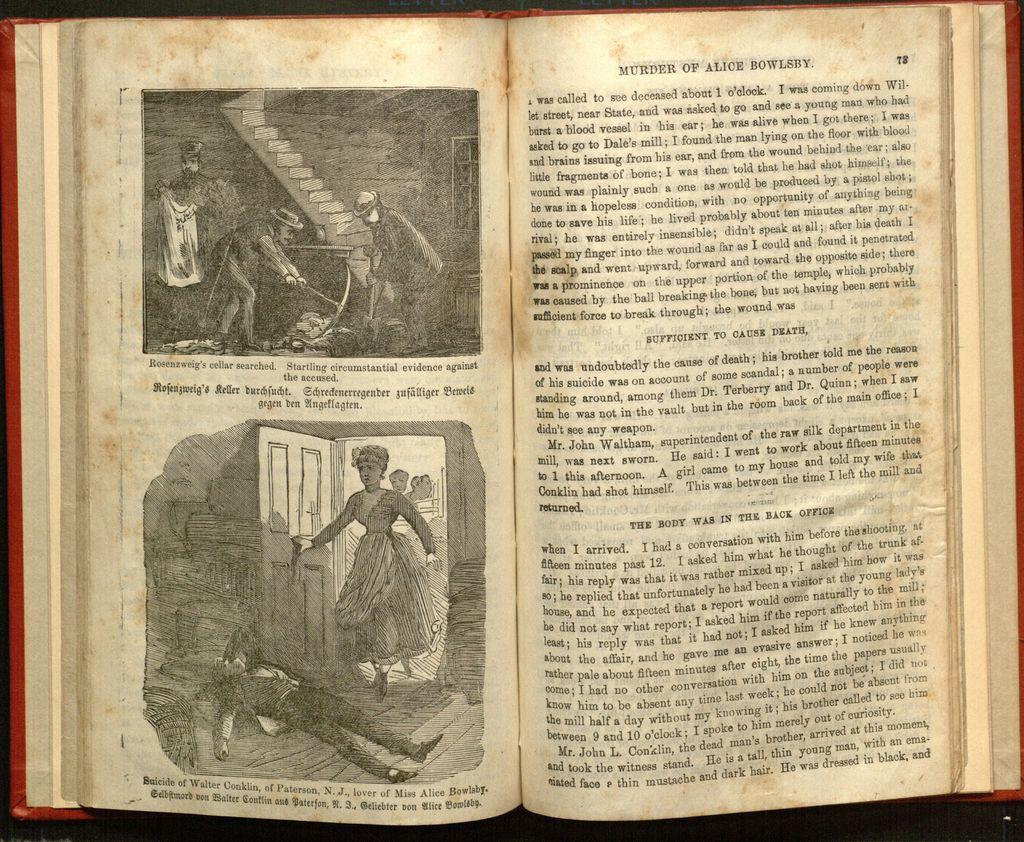What page number is on the right?
Your response must be concise. 78. 